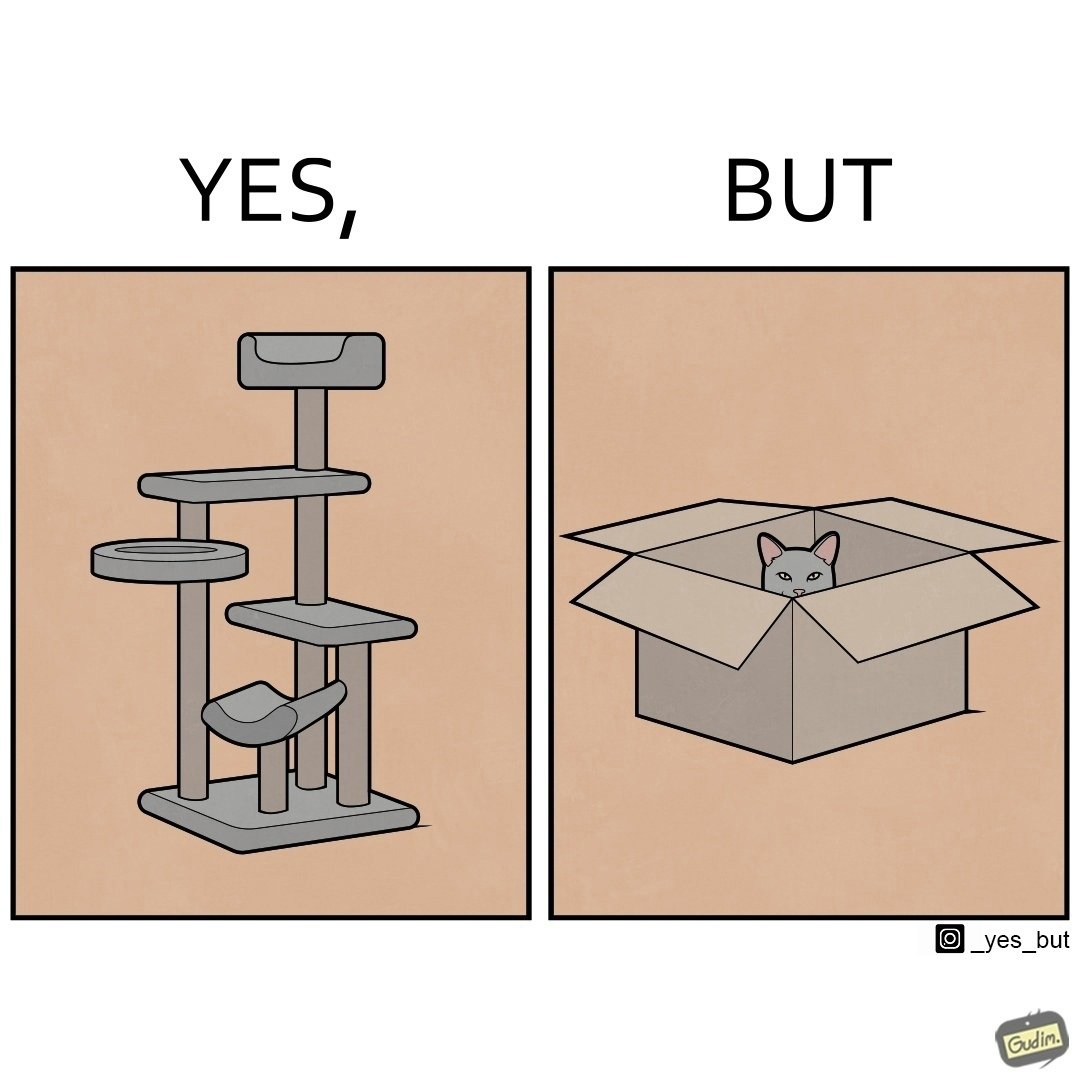Describe the contrast between the left and right parts of this image. In the left part of the image: It is a cat tree In the right part of the image: It is a cat in a cardboard box 